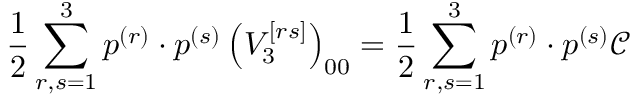<formula> <loc_0><loc_0><loc_500><loc_500>\frac { 1 } { 2 } \sum _ { r , s = 1 } ^ { 3 } p ^ { ( r ) } \cdot p ^ { ( s ) } \left ( V _ { 3 } ^ { \left [ r s \right ] } \right ) _ { 0 0 } = \frac { 1 } { 2 } \sum _ { r , s = 1 } ^ { 3 } p ^ { ( r ) } \cdot p ^ { ( s ) } \mathcal { C }</formula> 